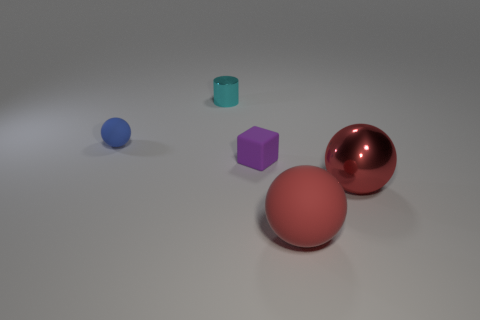Subtract all large red metallic balls. How many balls are left? 2 Subtract all cyan cubes. How many red spheres are left? 2 Subtract 1 spheres. How many spheres are left? 2 Subtract all blue spheres. How many spheres are left? 2 Subtract all purple spheres. Subtract all red cylinders. How many spheres are left? 3 Add 3 purple spheres. How many objects exist? 8 Subtract all cubes. How many objects are left? 4 Add 4 red metal things. How many red metal things are left? 5 Add 5 red matte balls. How many red matte balls exist? 6 Subtract 0 blue cubes. How many objects are left? 5 